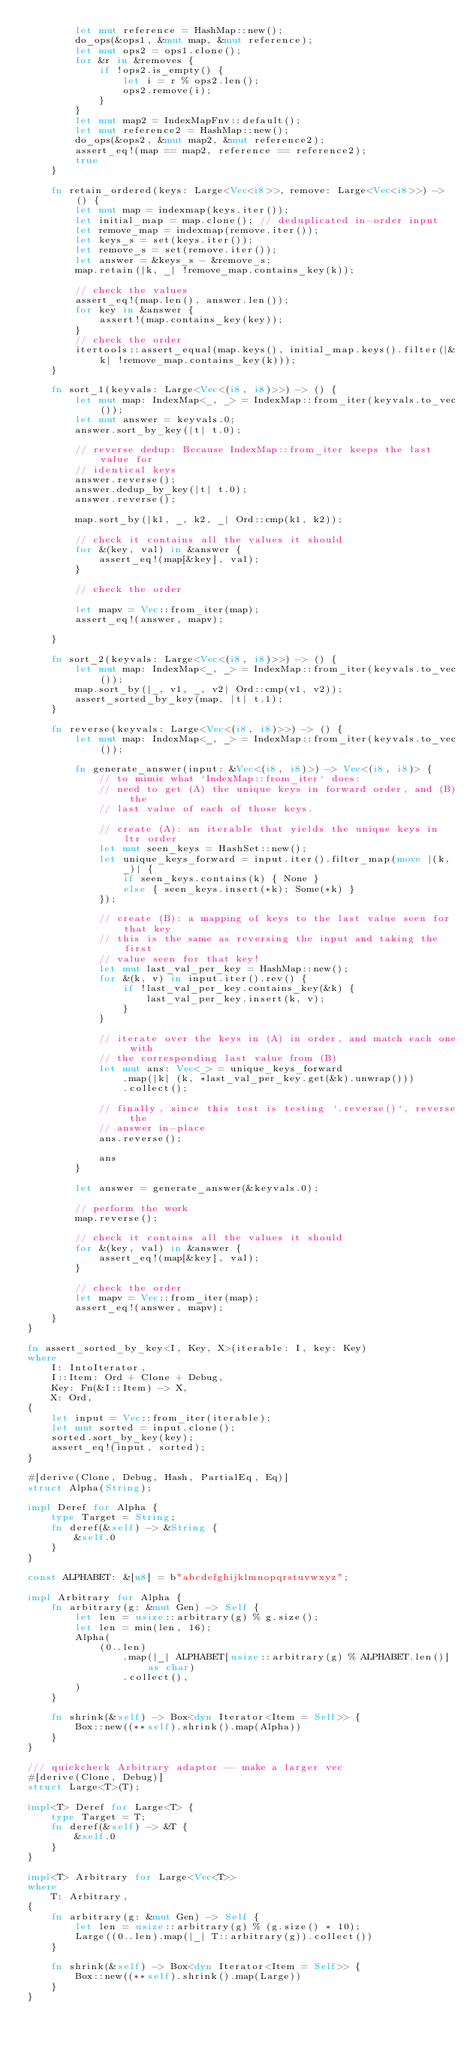<code> <loc_0><loc_0><loc_500><loc_500><_Rust_>        let mut reference = HashMap::new();
        do_ops(&ops1, &mut map, &mut reference);
        let mut ops2 = ops1.clone();
        for &r in &removes {
            if !ops2.is_empty() {
                let i = r % ops2.len();
                ops2.remove(i);
            }
        }
        let mut map2 = IndexMapFnv::default();
        let mut reference2 = HashMap::new();
        do_ops(&ops2, &mut map2, &mut reference2);
        assert_eq!(map == map2, reference == reference2);
        true
    }

    fn retain_ordered(keys: Large<Vec<i8>>, remove: Large<Vec<i8>>) -> () {
        let mut map = indexmap(keys.iter());
        let initial_map = map.clone(); // deduplicated in-order input
        let remove_map = indexmap(remove.iter());
        let keys_s = set(keys.iter());
        let remove_s = set(remove.iter());
        let answer = &keys_s - &remove_s;
        map.retain(|k, _| !remove_map.contains_key(k));

        // check the values
        assert_eq!(map.len(), answer.len());
        for key in &answer {
            assert!(map.contains_key(key));
        }
        // check the order
        itertools::assert_equal(map.keys(), initial_map.keys().filter(|&k| !remove_map.contains_key(k)));
    }

    fn sort_1(keyvals: Large<Vec<(i8, i8)>>) -> () {
        let mut map: IndexMap<_, _> = IndexMap::from_iter(keyvals.to_vec());
        let mut answer = keyvals.0;
        answer.sort_by_key(|t| t.0);

        // reverse dedup: Because IndexMap::from_iter keeps the last value for
        // identical keys
        answer.reverse();
        answer.dedup_by_key(|t| t.0);
        answer.reverse();

        map.sort_by(|k1, _, k2, _| Ord::cmp(k1, k2));

        // check it contains all the values it should
        for &(key, val) in &answer {
            assert_eq!(map[&key], val);
        }

        // check the order

        let mapv = Vec::from_iter(map);
        assert_eq!(answer, mapv);

    }

    fn sort_2(keyvals: Large<Vec<(i8, i8)>>) -> () {
        let mut map: IndexMap<_, _> = IndexMap::from_iter(keyvals.to_vec());
        map.sort_by(|_, v1, _, v2| Ord::cmp(v1, v2));
        assert_sorted_by_key(map, |t| t.1);
    }

    fn reverse(keyvals: Large<Vec<(i8, i8)>>) -> () {
        let mut map: IndexMap<_, _> = IndexMap::from_iter(keyvals.to_vec());

        fn generate_answer(input: &Vec<(i8, i8)>) -> Vec<(i8, i8)> {
            // to mimic what `IndexMap::from_iter` does:
            // need to get (A) the unique keys in forward order, and (B) the
            // last value of each of those keys.

            // create (A): an iterable that yields the unique keys in ltr order
            let mut seen_keys = HashSet::new();
            let unique_keys_forward = input.iter().filter_map(move |(k, _)| {
                if seen_keys.contains(k) { None }
                else { seen_keys.insert(*k); Some(*k) }
            });

            // create (B): a mapping of keys to the last value seen for that key
            // this is the same as reversing the input and taking the first
            // value seen for that key!
            let mut last_val_per_key = HashMap::new();
            for &(k, v) in input.iter().rev() {
                if !last_val_per_key.contains_key(&k) {
                    last_val_per_key.insert(k, v);
                }
            }

            // iterate over the keys in (A) in order, and match each one with
            // the corresponding last value from (B)
            let mut ans: Vec<_> = unique_keys_forward
                .map(|k| (k, *last_val_per_key.get(&k).unwrap()))
                .collect();

            // finally, since this test is testing `.reverse()`, reverse the
            // answer in-place
            ans.reverse();

            ans
        }

        let answer = generate_answer(&keyvals.0);

        // perform the work
        map.reverse();

        // check it contains all the values it should
        for &(key, val) in &answer {
            assert_eq!(map[&key], val);
        }

        // check the order
        let mapv = Vec::from_iter(map);
        assert_eq!(answer, mapv);
    }
}

fn assert_sorted_by_key<I, Key, X>(iterable: I, key: Key)
where
    I: IntoIterator,
    I::Item: Ord + Clone + Debug,
    Key: Fn(&I::Item) -> X,
    X: Ord,
{
    let input = Vec::from_iter(iterable);
    let mut sorted = input.clone();
    sorted.sort_by_key(key);
    assert_eq!(input, sorted);
}

#[derive(Clone, Debug, Hash, PartialEq, Eq)]
struct Alpha(String);

impl Deref for Alpha {
    type Target = String;
    fn deref(&self) -> &String {
        &self.0
    }
}

const ALPHABET: &[u8] = b"abcdefghijklmnopqrstuvwxyz";

impl Arbitrary for Alpha {
    fn arbitrary(g: &mut Gen) -> Self {
        let len = usize::arbitrary(g) % g.size();
        let len = min(len, 16);
        Alpha(
            (0..len)
                .map(|_| ALPHABET[usize::arbitrary(g) % ALPHABET.len()] as char)
                .collect(),
        )
    }

    fn shrink(&self) -> Box<dyn Iterator<Item = Self>> {
        Box::new((**self).shrink().map(Alpha))
    }
}

/// quickcheck Arbitrary adaptor -- make a larger vec
#[derive(Clone, Debug)]
struct Large<T>(T);

impl<T> Deref for Large<T> {
    type Target = T;
    fn deref(&self) -> &T {
        &self.0
    }
}

impl<T> Arbitrary for Large<Vec<T>>
where
    T: Arbitrary,
{
    fn arbitrary(g: &mut Gen) -> Self {
        let len = usize::arbitrary(g) % (g.size() * 10);
        Large((0..len).map(|_| T::arbitrary(g)).collect())
    }

    fn shrink(&self) -> Box<dyn Iterator<Item = Self>> {
        Box::new((**self).shrink().map(Large))
    }
}
</code> 